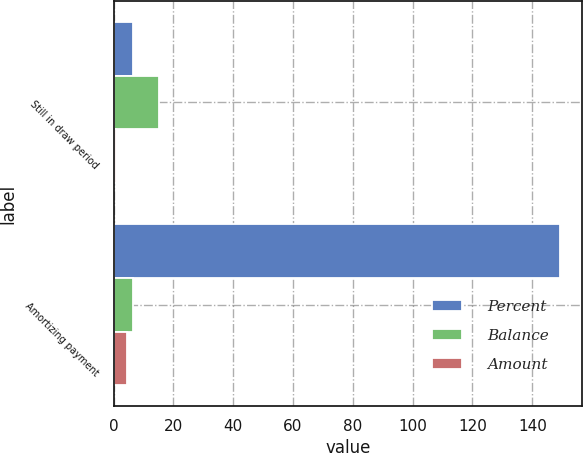<chart> <loc_0><loc_0><loc_500><loc_500><stacked_bar_chart><ecel><fcel>Still in draw period<fcel>Amortizing payment<nl><fcel>Percent<fcel>6.5<fcel>149.2<nl><fcel>Balance<fcel>15.1<fcel>6.5<nl><fcel>Amount<fcel>0.84<fcel>4.36<nl></chart> 